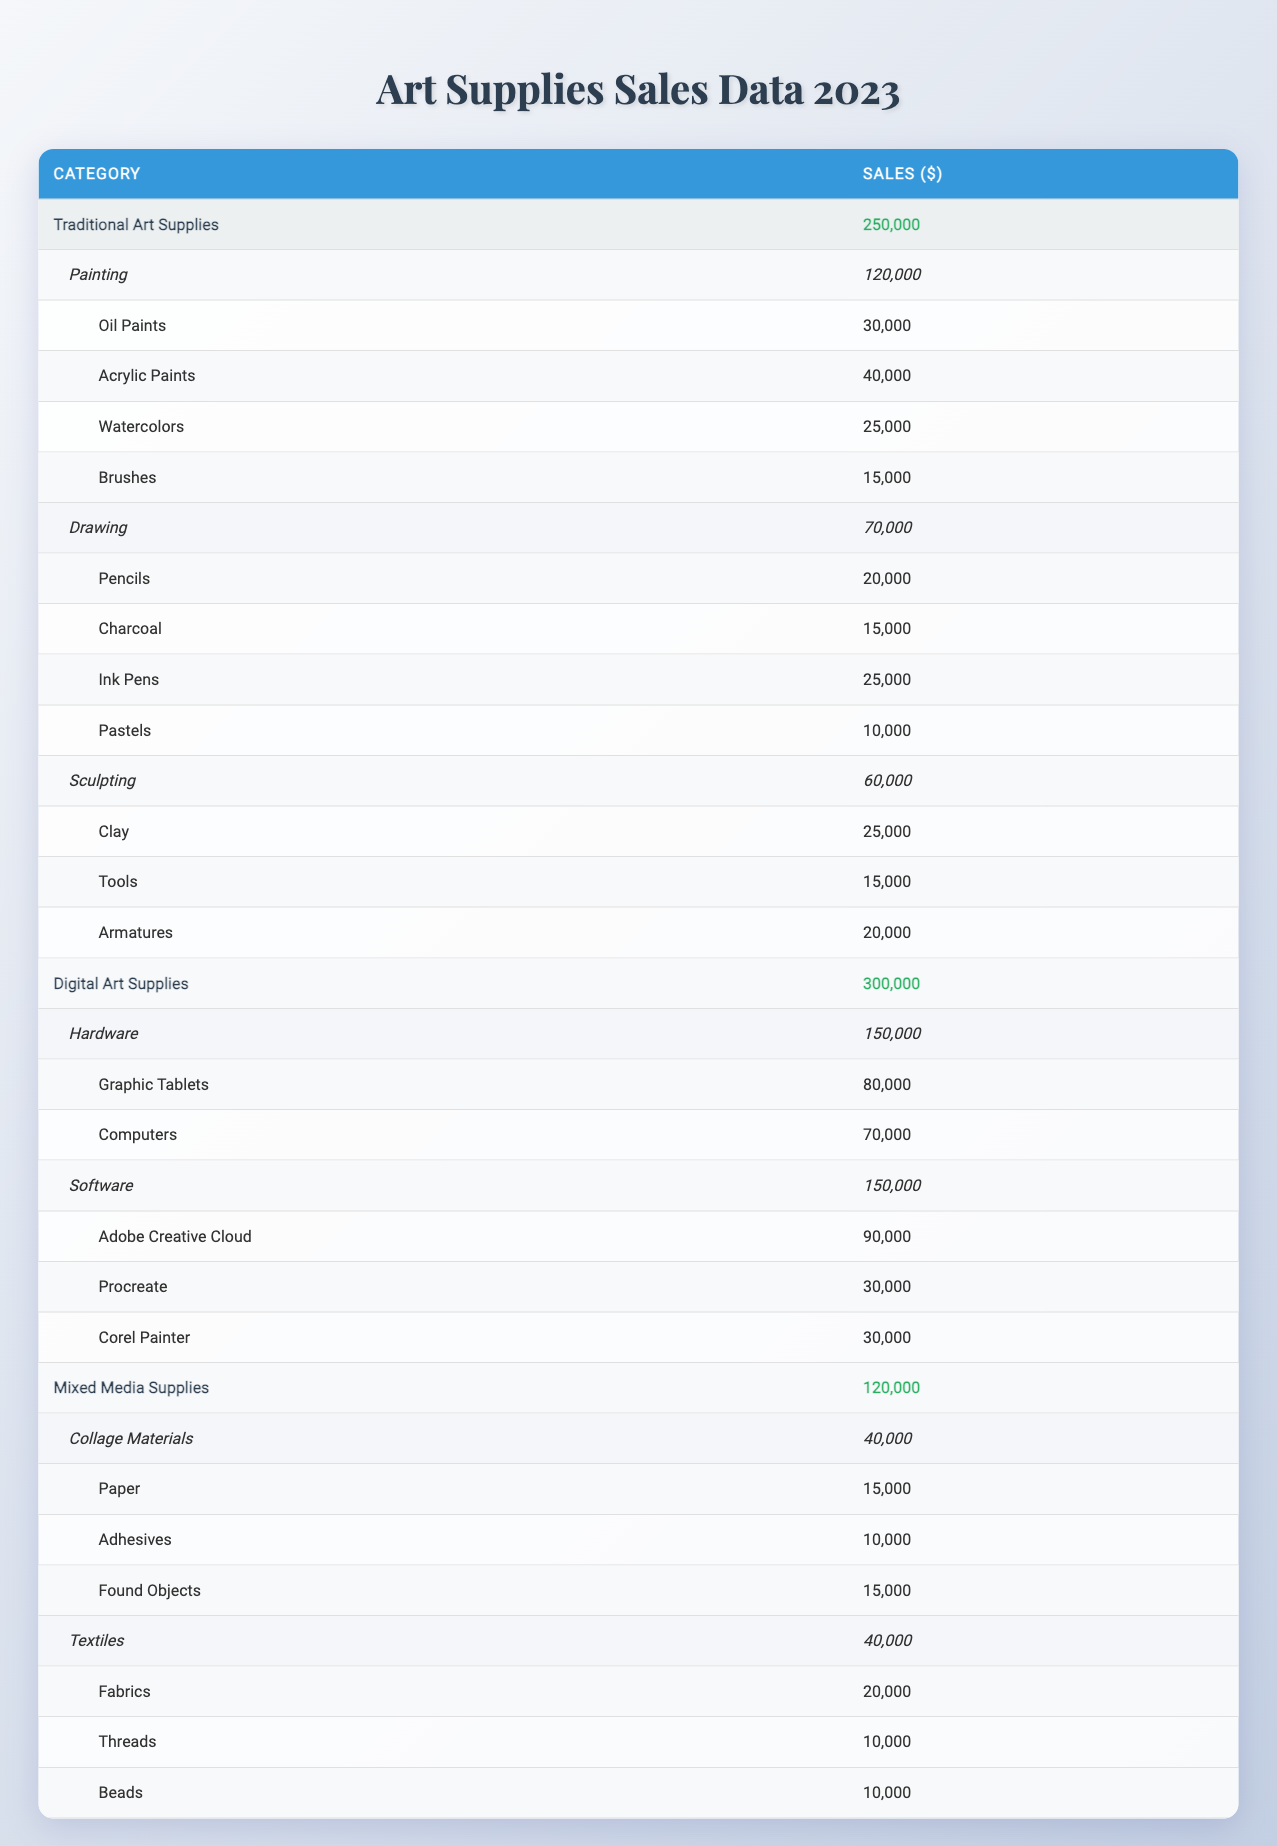What is the total sales for Digital Art Supplies? The total sales for Digital Art Supplies is listed directly in the table under its category as 300,000.
Answer: 300,000 How much did Painting supplies earn in total? The total sales for Painting supplies is provided directly in the table as 120,000.
Answer: 120,000 What are the total sales for Mixed Media Supplies? The total sales for Mixed Media Supplies is shown in the table as 120,000.
Answer: 120,000 Which subcategory under Traditional Art Supplies has the highest sales? According to the table, the subcategory Painting has the highest sales at 120,000 compared to Drawing (70,000) and Sculpting (60,000).
Answer: Painting How much more did Digital Art Supplies earn compared to Traditional Art Supplies? Total sales for Digital Art Supplies is 300,000 and for Traditional Art Supplies is 250,000. The difference is 300,000 - 250,000 = 50,000.
Answer: 50,000 What is the average sales of subcategories in the Digital Art Supplies category? There are two subcategories (Hardware and Software) each with total sales of 150,000. The average is (150,000 + 150,000) / 2 = 150,000.
Answer: 150,000 True or false: The total sales for Collage Materials are greater than 50,000. The total sales for Collage Materials is recorded at 40,000, which is less than 50,000, hence the statement is false.
Answer: False Which item in the Drawing subcategory has the lowest sales? Within the Drawing subcategory, Pastels has the lowest sales of 10,000 compared to Pencils (20,000), Charcoal (15,000), and Ink Pens (25,000).
Answer: Pastels What percentage of total sales in Traditional Art Supplies is attributed to Drawing? The Drawing subcategory has sales of 70,000, and the total sales for Traditional Art Supplies is 250,000. Therefore, the percentage is (70,000 / 250,000) * 100 = 28%.
Answer: 28% Which category has the highest sales overall? Digital Art Supplies has the highest overall sales of 300,000 compared to Traditional Art Supplies (250,000) and Mixed Media Supplies (120,000).
Answer: Digital Art Supplies 